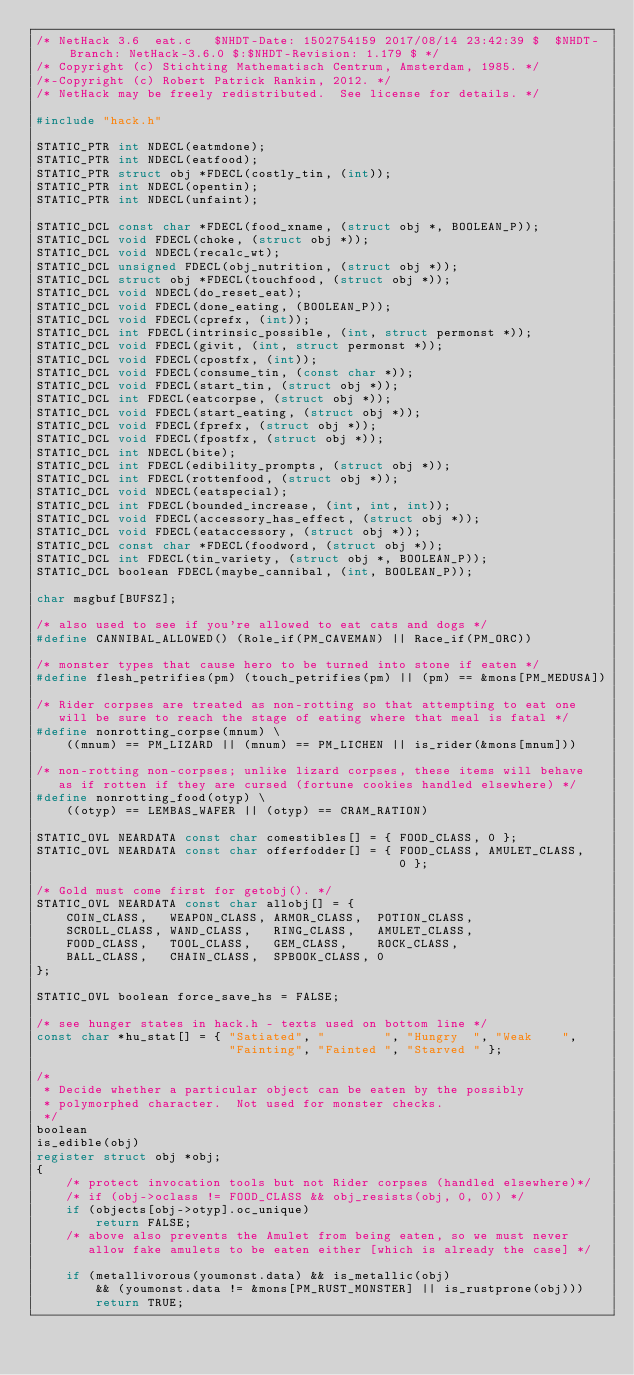Convert code to text. <code><loc_0><loc_0><loc_500><loc_500><_C_>/* NetHack 3.6	eat.c	$NHDT-Date: 1502754159 2017/08/14 23:42:39 $  $NHDT-Branch: NetHack-3.6.0 $:$NHDT-Revision: 1.179 $ */
/* Copyright (c) Stichting Mathematisch Centrum, Amsterdam, 1985. */
/*-Copyright (c) Robert Patrick Rankin, 2012. */
/* NetHack may be freely redistributed.  See license for details. */

#include "hack.h"

STATIC_PTR int NDECL(eatmdone);
STATIC_PTR int NDECL(eatfood);
STATIC_PTR struct obj *FDECL(costly_tin, (int));
STATIC_PTR int NDECL(opentin);
STATIC_PTR int NDECL(unfaint);

STATIC_DCL const char *FDECL(food_xname, (struct obj *, BOOLEAN_P));
STATIC_DCL void FDECL(choke, (struct obj *));
STATIC_DCL void NDECL(recalc_wt);
STATIC_DCL unsigned FDECL(obj_nutrition, (struct obj *));
STATIC_DCL struct obj *FDECL(touchfood, (struct obj *));
STATIC_DCL void NDECL(do_reset_eat);
STATIC_DCL void FDECL(done_eating, (BOOLEAN_P));
STATIC_DCL void FDECL(cprefx, (int));
STATIC_DCL int FDECL(intrinsic_possible, (int, struct permonst *));
STATIC_DCL void FDECL(givit, (int, struct permonst *));
STATIC_DCL void FDECL(cpostfx, (int));
STATIC_DCL void FDECL(consume_tin, (const char *));
STATIC_DCL void FDECL(start_tin, (struct obj *));
STATIC_DCL int FDECL(eatcorpse, (struct obj *));
STATIC_DCL void FDECL(start_eating, (struct obj *));
STATIC_DCL void FDECL(fprefx, (struct obj *));
STATIC_DCL void FDECL(fpostfx, (struct obj *));
STATIC_DCL int NDECL(bite);
STATIC_DCL int FDECL(edibility_prompts, (struct obj *));
STATIC_DCL int FDECL(rottenfood, (struct obj *));
STATIC_DCL void NDECL(eatspecial);
STATIC_DCL int FDECL(bounded_increase, (int, int, int));
STATIC_DCL void FDECL(accessory_has_effect, (struct obj *));
STATIC_DCL void FDECL(eataccessory, (struct obj *));
STATIC_DCL const char *FDECL(foodword, (struct obj *));
STATIC_DCL int FDECL(tin_variety, (struct obj *, BOOLEAN_P));
STATIC_DCL boolean FDECL(maybe_cannibal, (int, BOOLEAN_P));

char msgbuf[BUFSZ];

/* also used to see if you're allowed to eat cats and dogs */
#define CANNIBAL_ALLOWED() (Role_if(PM_CAVEMAN) || Race_if(PM_ORC))

/* monster types that cause hero to be turned into stone if eaten */
#define flesh_petrifies(pm) (touch_petrifies(pm) || (pm) == &mons[PM_MEDUSA])

/* Rider corpses are treated as non-rotting so that attempting to eat one
   will be sure to reach the stage of eating where that meal is fatal */
#define nonrotting_corpse(mnum) \
    ((mnum) == PM_LIZARD || (mnum) == PM_LICHEN || is_rider(&mons[mnum]))

/* non-rotting non-corpses; unlike lizard corpses, these items will behave
   as if rotten if they are cursed (fortune cookies handled elsewhere) */
#define nonrotting_food(otyp) \
    ((otyp) == LEMBAS_WAFER || (otyp) == CRAM_RATION)

STATIC_OVL NEARDATA const char comestibles[] = { FOOD_CLASS, 0 };
STATIC_OVL NEARDATA const char offerfodder[] = { FOOD_CLASS, AMULET_CLASS,
                                                 0 };

/* Gold must come first for getobj(). */
STATIC_OVL NEARDATA const char allobj[] = {
    COIN_CLASS,   WEAPON_CLASS, ARMOR_CLASS,  POTION_CLASS,
    SCROLL_CLASS, WAND_CLASS,   RING_CLASS,   AMULET_CLASS,
    FOOD_CLASS,   TOOL_CLASS,   GEM_CLASS,    ROCK_CLASS,
    BALL_CLASS,   CHAIN_CLASS,  SPBOOK_CLASS, 0
};

STATIC_OVL boolean force_save_hs = FALSE;

/* see hunger states in hack.h - texts used on bottom line */
const char *hu_stat[] = { "Satiated", "        ", "Hungry  ", "Weak    ",
                          "Fainting", "Fainted ", "Starved " };

/*
 * Decide whether a particular object can be eaten by the possibly
 * polymorphed character.  Not used for monster checks.
 */
boolean
is_edible(obj)
register struct obj *obj;
{
    /* protect invocation tools but not Rider corpses (handled elsewhere)*/
    /* if (obj->oclass != FOOD_CLASS && obj_resists(obj, 0, 0)) */
    if (objects[obj->otyp].oc_unique)
        return FALSE;
    /* above also prevents the Amulet from being eaten, so we must never
       allow fake amulets to be eaten either [which is already the case] */

    if (metallivorous(youmonst.data) && is_metallic(obj)
        && (youmonst.data != &mons[PM_RUST_MONSTER] || is_rustprone(obj)))
        return TRUE;
</code> 